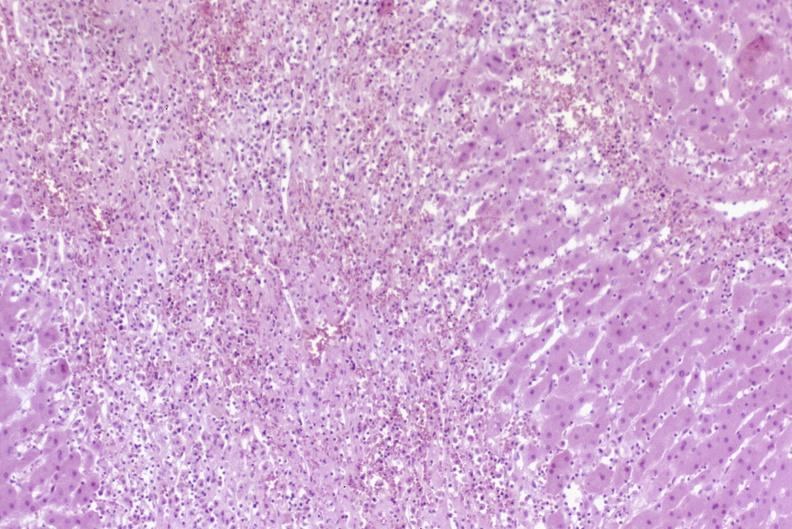s hepatobiliary present?
Answer the question using a single word or phrase. Yes 